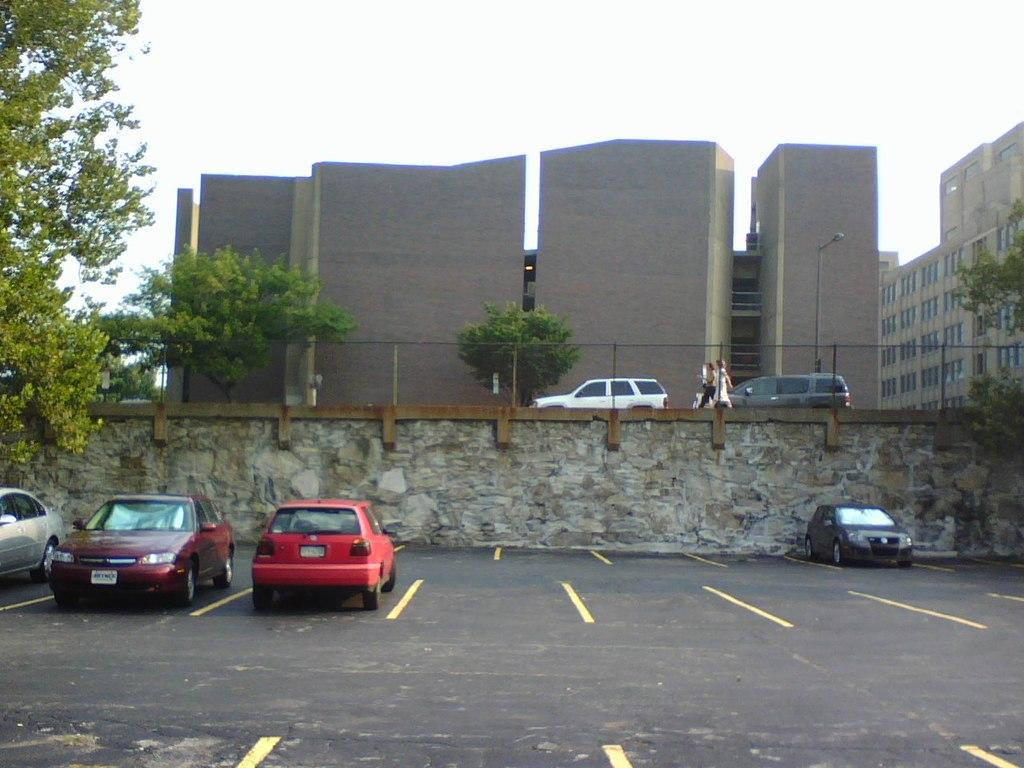What types of objects can be seen in the image? There are vehicles, trees, poles, buildings, and a fence in the image. Are there any living beings present in the image? Yes, there are people in the image. What can be seen beneath the objects and people in the image? The ground is visible in the image. What is visible above the objects and people in the image? The sky is visible in the image. What type of cloth is being used for the meeting in the image? There is no meeting or cloth present in the image. What is the range of the vehicles in the image? The range of the vehicles cannot be determined from the image, as it only shows them parked or stationary. 